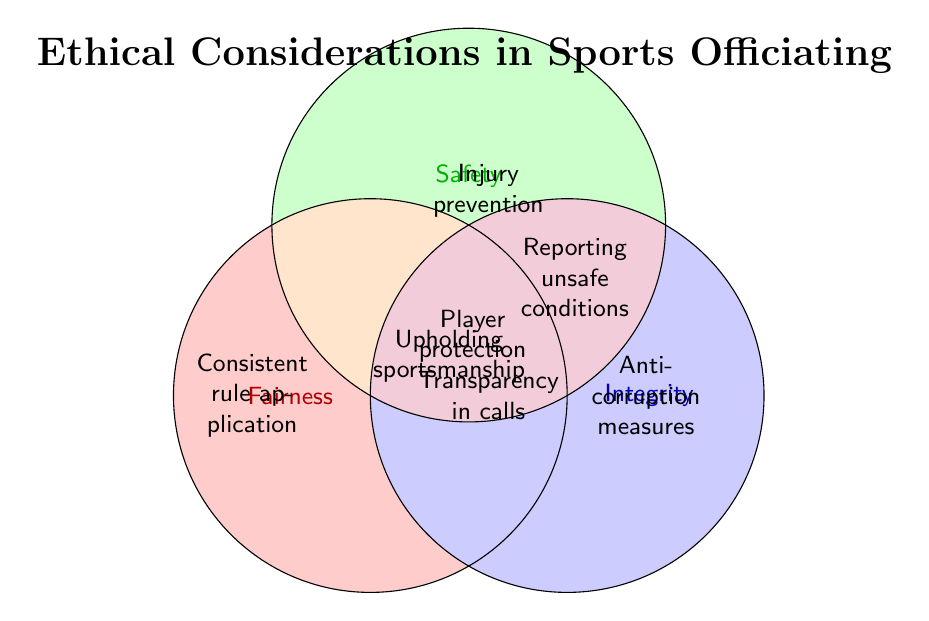What are the overlapping areas represented by yellow? The yellow overlap includes all three categories: Fairness, Safety, and Integrity. It specifically represents the items that fall under all three ethical considerations.
Answer: Fairness, Safety, Integrity Which category does "Injury prevention" belong to? "Injury prevention" is found within the Safety circle, as indicated by its placement and the label in the diagram.
Answer: Safety List the items that are in the intersection of Fairness and Integrity. The intersection of Fairness and Integrity includes items from both categories that overlap. According to the diagram, "Transparency in calls" is in this section.
Answer: Transparency in calls How many items are exclusive to the Fairness category? Items that are exclusive to Fairness do not overlap with Safety or Integrity. In the Fairness circle, these items are "Consistent rule application" and "Unbiased decision-making."
Answer: 2 Where can "Player protection" be found in the Venn diagram? "Player protection" is in the overlapping area of Fairness and Safety, not including Integrity. This is signified by its position in the diagram.
Answer: Fairness, Safety What item is shared by all three categories? The item that is common across Fairness, Safety, and Integrity appears in the center where all circles intersect. This item is "Upholding sportsmanship."
Answer: Upholding sportsmanship Compare the number of items shared between Fairness & Safety and Safety & Integrity. Which intersection has more? Fairness & Safety has one item ("Player protection"), while Safety & Integrity also has one item ("Reporting unsafe conditions"). Both intersections have the same number of items.
Answer: Equal What color represents the Integrity circle in the Venn diagram? The Integrity circle is shaded in blue, as indicated by the color coding in the diagram.
Answer: Blue Which categories overlap for "Reporting unsafe conditions"? "Reporting unsafe conditions" appears at the intersection of Safety and Integrity, showing that it relates to both categories.
Answer: Safety, Integrity 